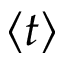<formula> <loc_0><loc_0><loc_500><loc_500>\langle t \rangle</formula> 